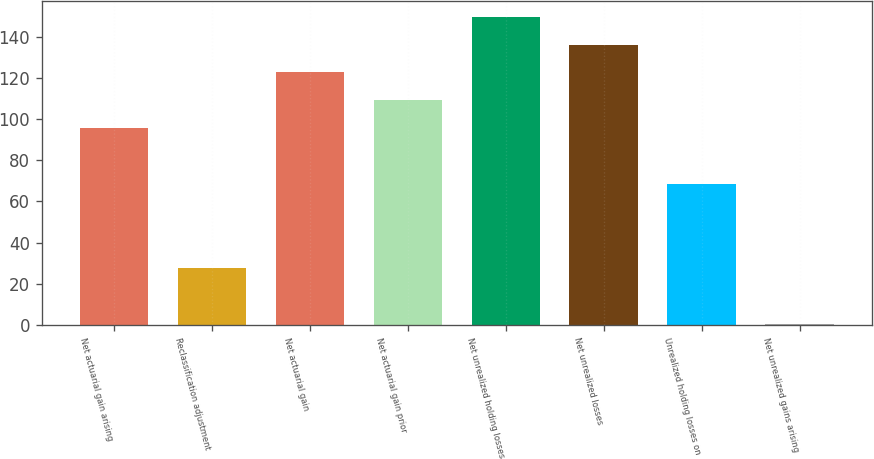Convert chart to OTSL. <chart><loc_0><loc_0><loc_500><loc_500><bar_chart><fcel>Net actuarial gain arising<fcel>Reclassification adjustment<fcel>Net actuarial gain<fcel>Net actuarial gain prior<fcel>Net unrealized holding losses<fcel>Net unrealized losses<fcel>Unrealized holding losses on<fcel>Net unrealized gains arising<nl><fcel>95.56<fcel>27.66<fcel>122.72<fcel>109.14<fcel>149.88<fcel>136.3<fcel>68.4<fcel>0.5<nl></chart> 